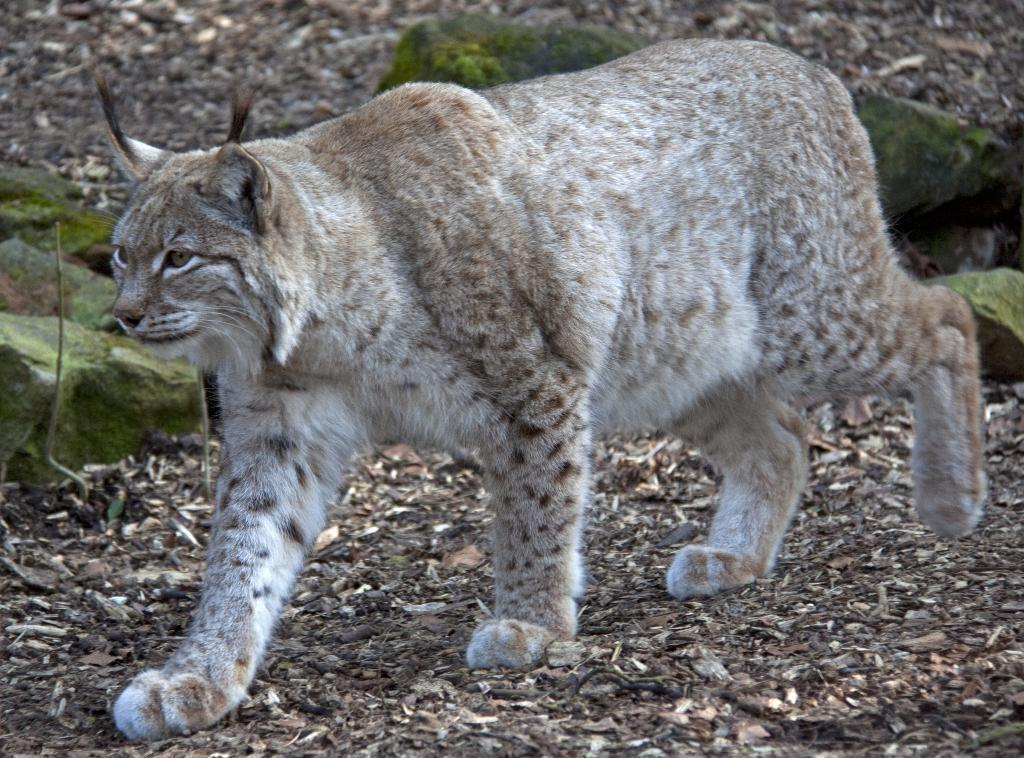What type of creature can be seen in the image? There is a wild animal in the image. What is the wild animal doing in the image? The wild animal is walking on the ground. What type of natural elements can be seen in the image? There are stones and leaves visible in the image. What songs is the wild animal singing in the image? There is no indication in the image that the wild animal is singing any songs. 